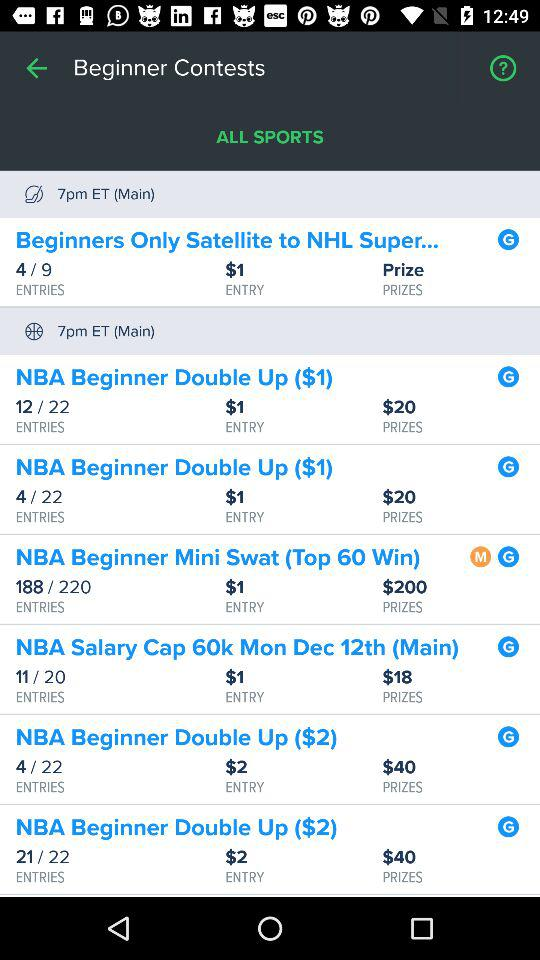What's the prize amount for "NBA Beginner Double Up ($1)"? The prize amount is $20. 